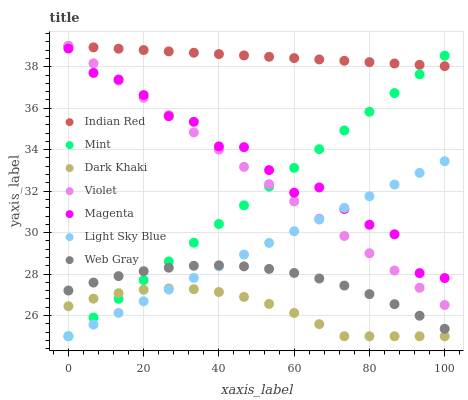Does Dark Khaki have the minimum area under the curve?
Answer yes or no. Yes. Does Indian Red have the maximum area under the curve?
Answer yes or no. Yes. Does Light Sky Blue have the minimum area under the curve?
Answer yes or no. No. Does Light Sky Blue have the maximum area under the curve?
Answer yes or no. No. Is Light Sky Blue the smoothest?
Answer yes or no. Yes. Is Magenta the roughest?
Answer yes or no. Yes. Is Dark Khaki the smoothest?
Answer yes or no. No. Is Dark Khaki the roughest?
Answer yes or no. No. Does Dark Khaki have the lowest value?
Answer yes or no. Yes. Does Indian Red have the lowest value?
Answer yes or no. No. Does Violet have the highest value?
Answer yes or no. Yes. Does Light Sky Blue have the highest value?
Answer yes or no. No. Is Dark Khaki less than Indian Red?
Answer yes or no. Yes. Is Indian Red greater than Dark Khaki?
Answer yes or no. Yes. Does Mint intersect Indian Red?
Answer yes or no. Yes. Is Mint less than Indian Red?
Answer yes or no. No. Is Mint greater than Indian Red?
Answer yes or no. No. Does Dark Khaki intersect Indian Red?
Answer yes or no. No. 